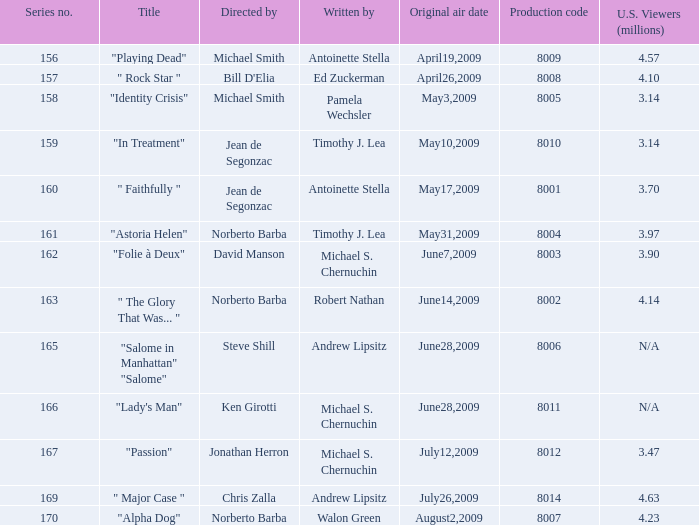Which is the  maximun serie episode number when the millions of north american spectators is 3.14? 159.0. 